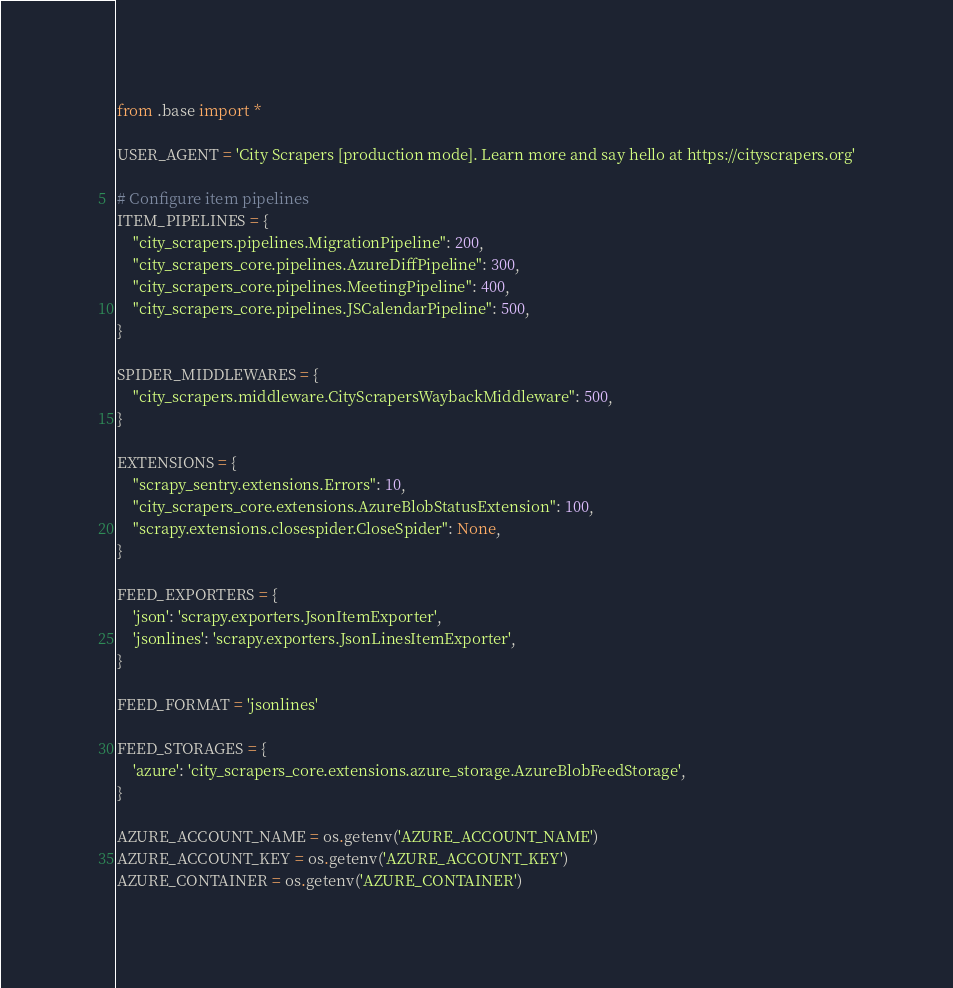<code> <loc_0><loc_0><loc_500><loc_500><_Python_>from .base import *

USER_AGENT = 'City Scrapers [production mode]. Learn more and say hello at https://cityscrapers.org'

# Configure item pipelines
ITEM_PIPELINES = {
    "city_scrapers.pipelines.MigrationPipeline": 200,
    "city_scrapers_core.pipelines.AzureDiffPipeline": 300,
    "city_scrapers_core.pipelines.MeetingPipeline": 400,
    "city_scrapers_core.pipelines.JSCalendarPipeline": 500,
}

SPIDER_MIDDLEWARES = {
    "city_scrapers.middleware.CityScrapersWaybackMiddleware": 500,
}

EXTENSIONS = {
    "scrapy_sentry.extensions.Errors": 10,
    "city_scrapers_core.extensions.AzureBlobStatusExtension": 100,
    "scrapy.extensions.closespider.CloseSpider": None,
}

FEED_EXPORTERS = {
    'json': 'scrapy.exporters.JsonItemExporter',
    'jsonlines': 'scrapy.exporters.JsonLinesItemExporter',
}

FEED_FORMAT = 'jsonlines'

FEED_STORAGES = {
    'azure': 'city_scrapers_core.extensions.azure_storage.AzureBlobFeedStorage',
}

AZURE_ACCOUNT_NAME = os.getenv('AZURE_ACCOUNT_NAME')
AZURE_ACCOUNT_KEY = os.getenv('AZURE_ACCOUNT_KEY')
AZURE_CONTAINER = os.getenv('AZURE_CONTAINER')
</code> 